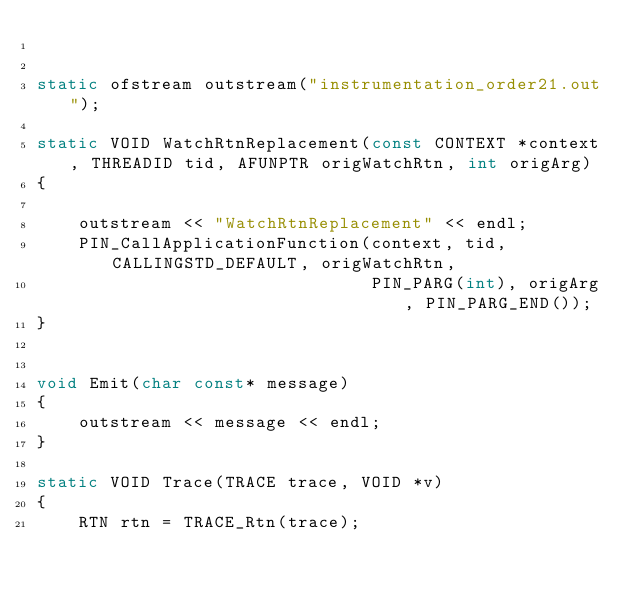Convert code to text. <code><loc_0><loc_0><loc_500><loc_500><_C++_>

static ofstream outstream("instrumentation_order21.out");
    
static VOID WatchRtnReplacement(const CONTEXT *context, THREADID tid, AFUNPTR origWatchRtn, int origArg)
{
    
    outstream << "WatchRtnReplacement" << endl;
    PIN_CallApplicationFunction(context, tid, CALLINGSTD_DEFAULT, origWatchRtn,
                                PIN_PARG(int), origArg, PIN_PARG_END());
}


void Emit(char const* message)
{
    outstream << message << endl;
}

static VOID Trace(TRACE trace, VOID *v)
{
    RTN rtn = TRACE_Rtn(trace);
    </code> 